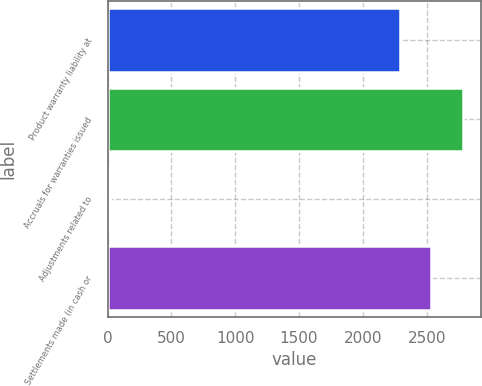<chart> <loc_0><loc_0><loc_500><loc_500><bar_chart><fcel>Product warranty liability at<fcel>Accruals for warranties issued<fcel>Adjustments related to<fcel>Settlements made (in cash or<nl><fcel>2288.5<fcel>2785.5<fcel>17<fcel>2537<nl></chart> 